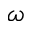<formula> <loc_0><loc_0><loc_500><loc_500>\omega</formula> 